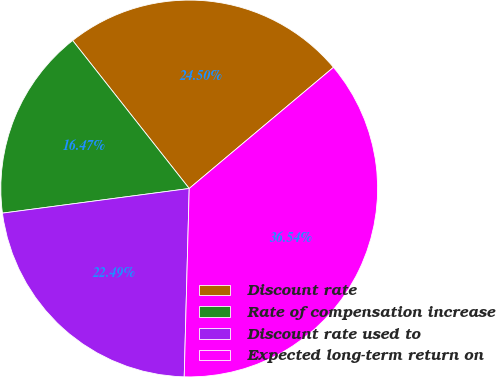<chart> <loc_0><loc_0><loc_500><loc_500><pie_chart><fcel>Discount rate<fcel>Rate of compensation increase<fcel>Discount rate used to<fcel>Expected long-term return on<nl><fcel>24.5%<fcel>16.47%<fcel>22.49%<fcel>36.54%<nl></chart> 